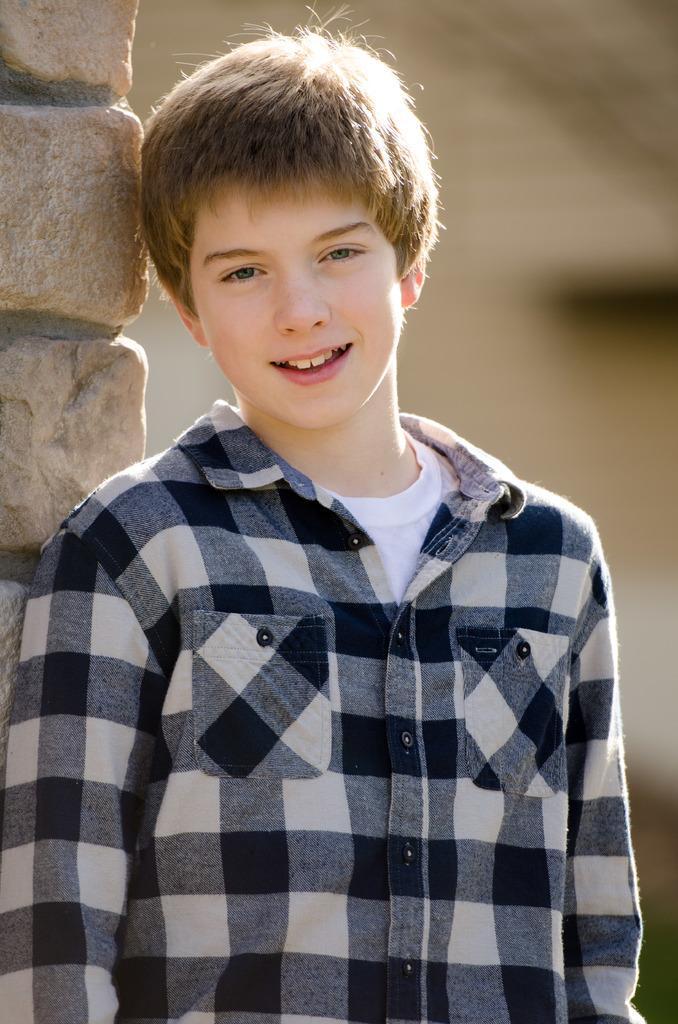How would you summarize this image in a sentence or two? In this image I can see a boy is standing in the front, I can see he is wearing check shirt and white t shirt. I can also see this image is blurry in the background and on the left side of this image I can see the wall. 